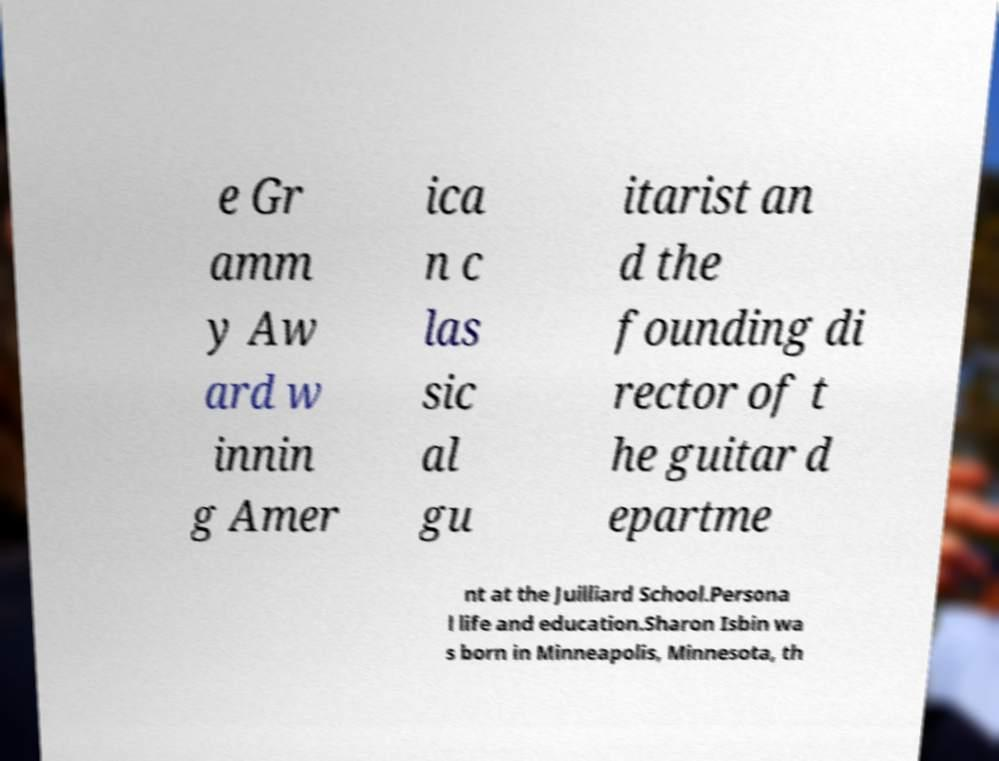Could you extract and type out the text from this image? e Gr amm y Aw ard w innin g Amer ica n c las sic al gu itarist an d the founding di rector of t he guitar d epartme nt at the Juilliard School.Persona l life and education.Sharon Isbin wa s born in Minneapolis, Minnesota, th 